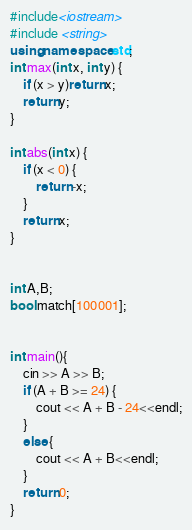<code> <loc_0><loc_0><loc_500><loc_500><_C++_>#include<iostream>
#include <string> 
using namespace std;
int max(int x, int y) {
	if (x > y)return x;
	return y;
}

int abs(int x) {
	if (x < 0) {
		return -x;
	}
	return x;
}


int A,B;
bool match[100001];


int main(){
	cin >> A >> B;
	if (A + B >= 24) {
		cout << A + B - 24<<endl;
	}
	else {
		cout << A + B<<endl;
	}
	return 0;
}</code> 